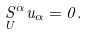Convert formula to latex. <formula><loc_0><loc_0><loc_500><loc_500>\underset { U } { S } ^ { \alpha } u _ { \alpha } = 0 .</formula> 